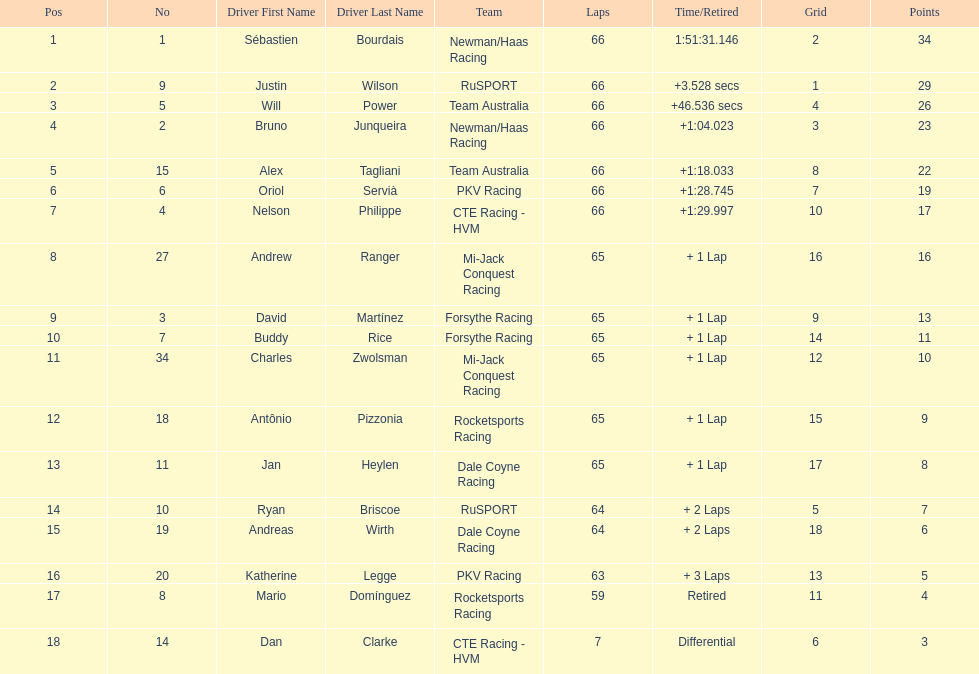What is the number of laps dan clarke completed? 7. Would you be able to parse every entry in this table? {'header': ['Pos', 'No', 'Driver First Name', 'Driver Last Name', 'Team', 'Laps', 'Time/Retired', 'Grid', 'Points'], 'rows': [['1', '1', 'Sébastien', 'Bourdais', 'Newman/Haas Racing', '66', '1:51:31.146', '2', '34'], ['2', '9', 'Justin', 'Wilson', 'RuSPORT', '66', '+3.528 secs', '1', '29'], ['3', '5', 'Will', 'Power', 'Team Australia', '66', '+46.536 secs', '4', '26'], ['4', '2', 'Bruno', 'Junqueira', 'Newman/Haas Racing', '66', '+1:04.023', '3', '23'], ['5', '15', 'Alex', 'Tagliani', 'Team Australia', '66', '+1:18.033', '8', '22'], ['6', '6', 'Oriol', 'Servià', 'PKV Racing', '66', '+1:28.745', '7', '19'], ['7', '4', 'Nelson', 'Philippe', 'CTE Racing - HVM', '66', '+1:29.997', '10', '17'], ['8', '27', 'Andrew', 'Ranger', 'Mi-Jack Conquest Racing', '65', '+ 1 Lap', '16', '16'], ['9', '3', 'David', 'Martínez', 'Forsythe Racing', '65', '+ 1 Lap', '9', '13'], ['10', '7', 'Buddy', 'Rice', 'Forsythe Racing', '65', '+ 1 Lap', '14', '11'], ['11', '34', 'Charles', 'Zwolsman', 'Mi-Jack Conquest Racing', '65', '+ 1 Lap', '12', '10'], ['12', '18', 'Antônio', 'Pizzonia', 'Rocketsports Racing', '65', '+ 1 Lap', '15', '9'], ['13', '11', 'Jan', 'Heylen', 'Dale Coyne Racing', '65', '+ 1 Lap', '17', '8'], ['14', '10', 'Ryan', 'Briscoe', 'RuSPORT', '64', '+ 2 Laps', '5', '7'], ['15', '19', 'Andreas', 'Wirth', 'Dale Coyne Racing', '64', '+ 2 Laps', '18', '6'], ['16', '20', 'Katherine', 'Legge', 'PKV Racing', '63', '+ 3 Laps', '13', '5'], ['17', '8', 'Mario', 'Domínguez', 'Rocketsports Racing', '59', 'Retired', '11', '4'], ['18', '14', 'Dan', 'Clarke', 'CTE Racing - HVM', '7', 'Differential', '6', '3']]} 